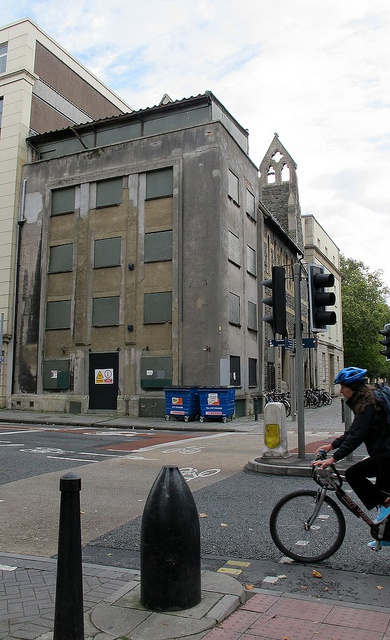Describe the objects in this image and their specific colors. I can see people in lightgray, black, gray, darkgray, and navy tones, bicycle in lightgray, gray, black, and darkgray tones, traffic light in lightgray, black, gray, and darkgray tones, traffic light in lightgray, black, and gray tones, and traffic light in lightgray, black, gray, and darkgray tones in this image. 